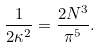Convert formula to latex. <formula><loc_0><loc_0><loc_500><loc_500>\frac { 1 } { 2 \kappa ^ { 2 } } = \frac { 2 N ^ { 3 } } { \pi ^ { 5 } } .</formula> 